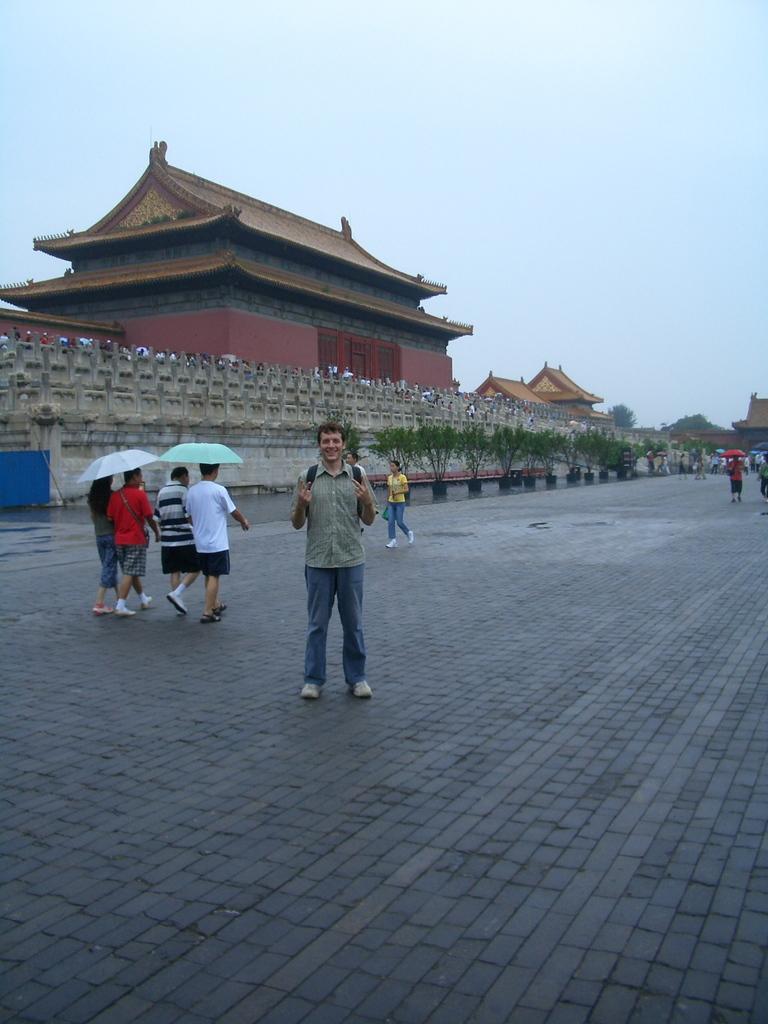How would you summarize this image in a sentence or two? In this picture I can see a man standing on a walkway. I can see a few people walking on the walk way with umbrella. I can see an ancient construction with wall fencing around it. I can see clouds in the sky. 